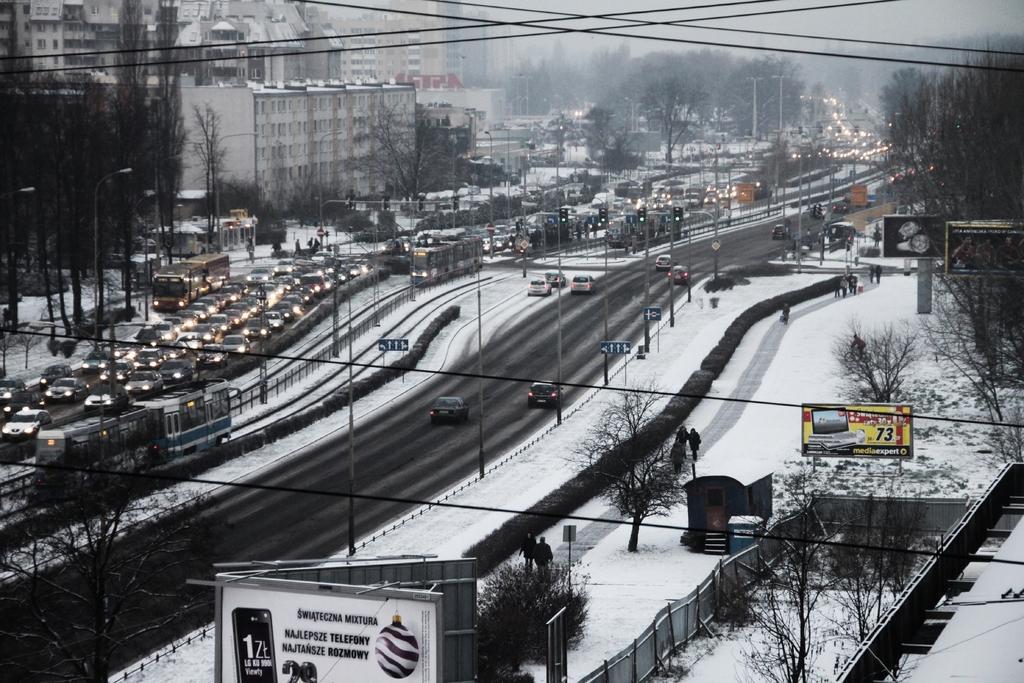In one or two sentences, can you explain what this image depicts? This is a picture of a city. In the foreground of the picture there are roads, trees, hoardings, people and snow. On the left there are vehicles, trees and buildings. In the center of the picture there are current poles, fencing, vehicles, hoardings and trees. In the background there are trees, poles and buildings. 